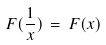Convert formula to latex. <formula><loc_0><loc_0><loc_500><loc_500>F ( \frac { 1 } { x } ) \, = \, F ( x )</formula> 